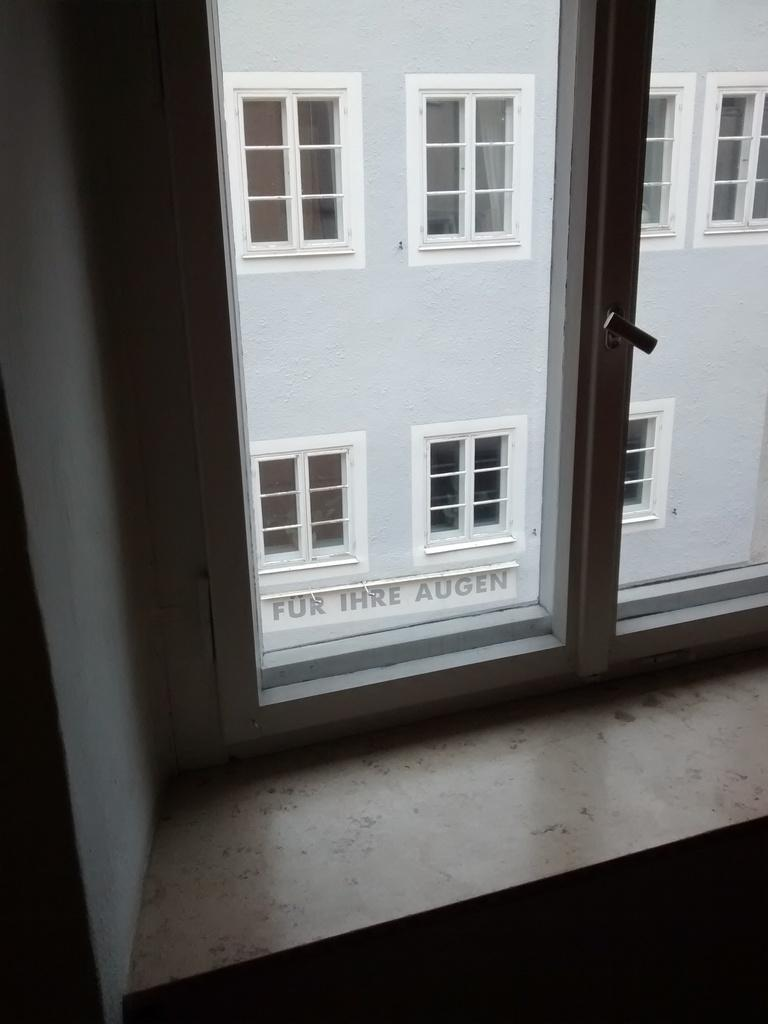What can be seen through the window in the image? A building with windows is visible through the window in the image. What is located on the left side of the image? There is a wall on the left side of the image. Can you describe the window in the image? The window allows a view of the building with windows. Is there a dog using a rake to burst through the wall in the image? No, there is no dog or rake present in the image, and the wall is not being burst through. 